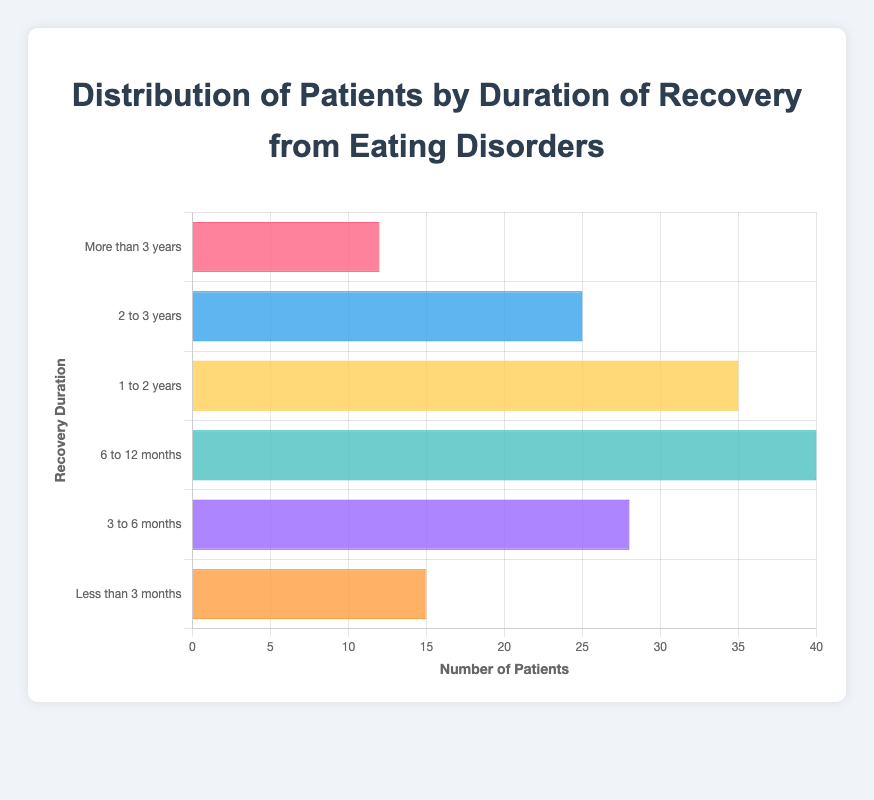What is the total number of patients who took less than 1 year to recover? To find the total number of patients who took less than 1 year to recover, sum the patients for the durations "Less than 3 months" (15 patients), "3 to 6 months" (28 patients), and "6 to 12 months" (40 patients). The total is 15 + 28 + 40 = 83.
Answer: 83 Which duration of recovery has the highest number of patients? To determine which duration of recovery has the highest number of patients, compare the numbers: 15 (Less than 3 months), 28 (3 to 6 months), 40 (6 to 12 months), 35 (1 to 2 years), 25 (2 to 3 years), and 12 (More than 3 years). 6 to 12 months has the highest count of 40 patients.
Answer: 6 to 12 months How many more patients took 6 to 12 months to recover compared to those who took 2 to 3 years? To find out how many more patients took 6 to 12 months (40) compared to 2 to 3 years (25), subtract the smaller number from the larger: 40 - 25 = 15.
Answer: 15 What is the combined number of patients who took between 1 to 3 years to recover? To get the combined number of patients who took between 1 to 3 years, add the number of patients for "1 to 2 years" (35) and "2 to 3 years" (25). The sum is 35 + 25 = 60.
Answer: 60 Among all durations, which one has the least number of patients? To find the duration with the least number of patients, compare the values: 15, 28, 40, 35, 25, and 12. The smallest value is 12, which corresponds to the duration "More than 3 years".
Answer: More than 3 years How does the number of patients who took less than 3 months compare to those who took more than 3 years? Compare the values for "Less than 3 months" (15 patients) and "More than 3 years" (12 patients). Since 15 is greater than 12, more patients took less than 3 months to recover compared to more than 3 years.
Answer: More patients took less than 3 months What is the average number of patients across all recovery durations? To calculate the average number of patients, sum all patients and divide by the number of durations. The sum is 15 + 28 + 40 + 35 + 25 + 12 = 155. There are 6 durations, so the average is 155 / 6 ≈ 25.83.
Answer: 25.83 Which recovery duration uses a blue visual representation in the chart? Observing the color details, "2 to 3 years" uses the blue color in the chart.
Answer: 2 to 3 years 